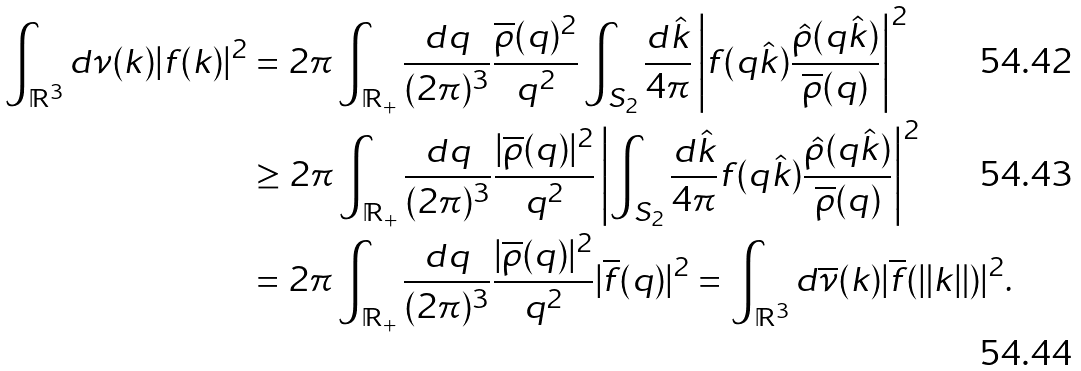Convert formula to latex. <formula><loc_0><loc_0><loc_500><loc_500>\int _ { \mathbb { R } ^ { 3 } } d \nu ( k ) | f ( k ) | ^ { 2 } & = 2 \pi \int _ { \mathbb { R } _ { + } } \frac { d q } { ( 2 \pi ) ^ { 3 } } \frac { \overline { \rho } ( q ) ^ { 2 } } { q ^ { 2 } } \int _ { S _ { 2 } } \frac { d \hat { k } } { 4 \pi } \left | f ( q \hat { k } ) \frac { \hat { \rho } ( q \hat { k } ) } { \overline { \rho } ( q ) } \right | ^ { 2 } \\ & \geq 2 \pi \int _ { \mathbb { R } _ { + } } \frac { d q } { ( 2 \pi ) ^ { 3 } } \frac { | \overline { \rho } ( q ) | ^ { 2 } } { q ^ { 2 } } \left | \int _ { S _ { 2 } } \frac { d \hat { k } } { 4 \pi } f ( q \hat { k } ) \frac { \hat { \rho } ( q \hat { k } ) } { \overline { \rho } ( q ) } \right | ^ { 2 } \\ & = 2 \pi \int _ { \mathbb { R } _ { + } } \frac { d q } { ( 2 \pi ) ^ { 3 } } \frac { | \overline { \rho } ( q ) | ^ { 2 } } { q ^ { 2 } } | \overline { f } ( q ) | ^ { 2 } = \int _ { \mathbb { R } ^ { 3 } } d \overline { \nu } ( k ) | \overline { f } ( \| k \| ) | ^ { 2 } .</formula> 